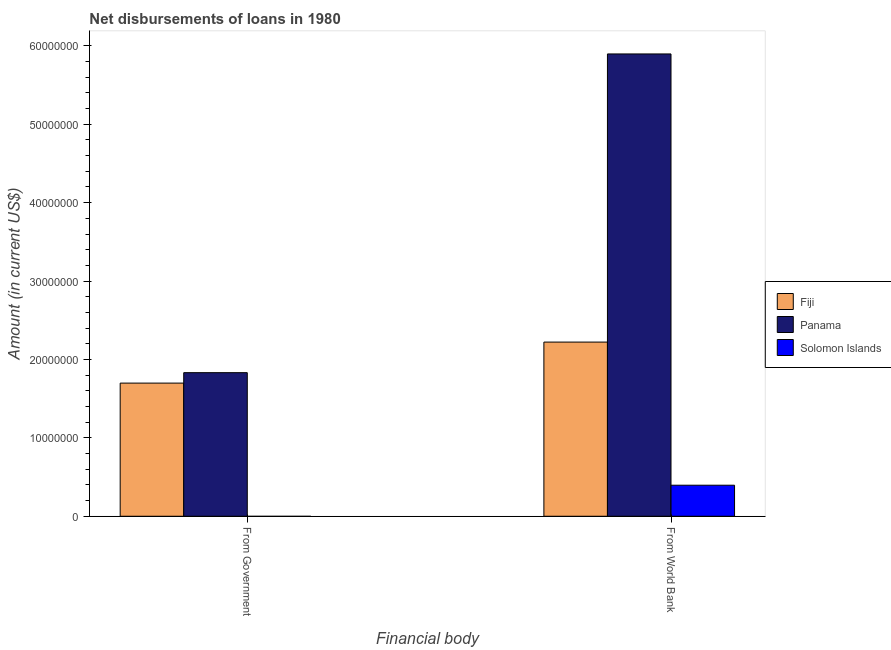How many different coloured bars are there?
Your answer should be very brief. 3. How many groups of bars are there?
Make the answer very short. 2. What is the label of the 1st group of bars from the left?
Your response must be concise. From Government. What is the net disbursements of loan from government in Panama?
Your answer should be very brief. 1.83e+07. Across all countries, what is the maximum net disbursements of loan from world bank?
Keep it short and to the point. 5.90e+07. Across all countries, what is the minimum net disbursements of loan from government?
Make the answer very short. 0. In which country was the net disbursements of loan from world bank maximum?
Give a very brief answer. Panama. What is the total net disbursements of loan from government in the graph?
Keep it short and to the point. 3.53e+07. What is the difference between the net disbursements of loan from world bank in Panama and that in Fiji?
Your response must be concise. 3.68e+07. What is the difference between the net disbursements of loan from government in Panama and the net disbursements of loan from world bank in Solomon Islands?
Your answer should be compact. 1.44e+07. What is the average net disbursements of loan from world bank per country?
Your answer should be very brief. 2.84e+07. What is the difference between the net disbursements of loan from government and net disbursements of loan from world bank in Fiji?
Your answer should be compact. -5.23e+06. In how many countries, is the net disbursements of loan from government greater than 10000000 US$?
Your answer should be very brief. 2. What is the ratio of the net disbursements of loan from world bank in Fiji to that in Panama?
Give a very brief answer. 0.38. How many bars are there?
Provide a short and direct response. 5. Are all the bars in the graph horizontal?
Provide a succinct answer. No. What is the difference between two consecutive major ticks on the Y-axis?
Keep it short and to the point. 1.00e+07. Are the values on the major ticks of Y-axis written in scientific E-notation?
Ensure brevity in your answer.  No. Does the graph contain any zero values?
Offer a terse response. Yes. Does the graph contain grids?
Offer a very short reply. No. How are the legend labels stacked?
Make the answer very short. Vertical. What is the title of the graph?
Provide a succinct answer. Net disbursements of loans in 1980. Does "Middle East & North Africa (developing only)" appear as one of the legend labels in the graph?
Offer a very short reply. No. What is the label or title of the X-axis?
Your response must be concise. Financial body. What is the Amount (in current US$) of Fiji in From Government?
Provide a short and direct response. 1.70e+07. What is the Amount (in current US$) in Panama in From Government?
Provide a short and direct response. 1.83e+07. What is the Amount (in current US$) of Fiji in From World Bank?
Offer a terse response. 2.22e+07. What is the Amount (in current US$) of Panama in From World Bank?
Provide a short and direct response. 5.90e+07. What is the Amount (in current US$) of Solomon Islands in From World Bank?
Give a very brief answer. 3.96e+06. Across all Financial body, what is the maximum Amount (in current US$) in Fiji?
Your response must be concise. 2.22e+07. Across all Financial body, what is the maximum Amount (in current US$) in Panama?
Keep it short and to the point. 5.90e+07. Across all Financial body, what is the maximum Amount (in current US$) of Solomon Islands?
Keep it short and to the point. 3.96e+06. Across all Financial body, what is the minimum Amount (in current US$) of Fiji?
Your answer should be compact. 1.70e+07. Across all Financial body, what is the minimum Amount (in current US$) of Panama?
Give a very brief answer. 1.83e+07. Across all Financial body, what is the minimum Amount (in current US$) in Solomon Islands?
Provide a succinct answer. 0. What is the total Amount (in current US$) of Fiji in the graph?
Give a very brief answer. 3.92e+07. What is the total Amount (in current US$) of Panama in the graph?
Make the answer very short. 7.73e+07. What is the total Amount (in current US$) in Solomon Islands in the graph?
Your response must be concise. 3.96e+06. What is the difference between the Amount (in current US$) of Fiji in From Government and that in From World Bank?
Offer a terse response. -5.23e+06. What is the difference between the Amount (in current US$) in Panama in From Government and that in From World Bank?
Give a very brief answer. -4.07e+07. What is the difference between the Amount (in current US$) of Fiji in From Government and the Amount (in current US$) of Panama in From World Bank?
Give a very brief answer. -4.20e+07. What is the difference between the Amount (in current US$) in Fiji in From Government and the Amount (in current US$) in Solomon Islands in From World Bank?
Keep it short and to the point. 1.30e+07. What is the difference between the Amount (in current US$) in Panama in From Government and the Amount (in current US$) in Solomon Islands in From World Bank?
Offer a terse response. 1.44e+07. What is the average Amount (in current US$) in Fiji per Financial body?
Your answer should be compact. 1.96e+07. What is the average Amount (in current US$) in Panama per Financial body?
Your answer should be compact. 3.86e+07. What is the average Amount (in current US$) of Solomon Islands per Financial body?
Your answer should be very brief. 1.98e+06. What is the difference between the Amount (in current US$) of Fiji and Amount (in current US$) of Panama in From Government?
Offer a terse response. -1.33e+06. What is the difference between the Amount (in current US$) of Fiji and Amount (in current US$) of Panama in From World Bank?
Provide a succinct answer. -3.68e+07. What is the difference between the Amount (in current US$) of Fiji and Amount (in current US$) of Solomon Islands in From World Bank?
Make the answer very short. 1.83e+07. What is the difference between the Amount (in current US$) of Panama and Amount (in current US$) of Solomon Islands in From World Bank?
Your response must be concise. 5.50e+07. What is the ratio of the Amount (in current US$) in Fiji in From Government to that in From World Bank?
Your answer should be very brief. 0.76. What is the ratio of the Amount (in current US$) in Panama in From Government to that in From World Bank?
Your answer should be very brief. 0.31. What is the difference between the highest and the second highest Amount (in current US$) in Fiji?
Make the answer very short. 5.23e+06. What is the difference between the highest and the second highest Amount (in current US$) in Panama?
Ensure brevity in your answer.  4.07e+07. What is the difference between the highest and the lowest Amount (in current US$) of Fiji?
Provide a succinct answer. 5.23e+06. What is the difference between the highest and the lowest Amount (in current US$) in Panama?
Your answer should be very brief. 4.07e+07. What is the difference between the highest and the lowest Amount (in current US$) in Solomon Islands?
Offer a very short reply. 3.96e+06. 